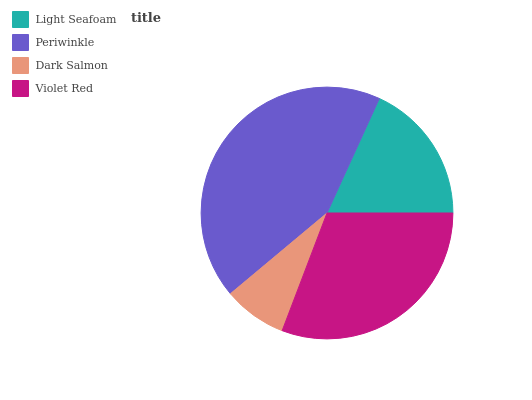Is Dark Salmon the minimum?
Answer yes or no. Yes. Is Periwinkle the maximum?
Answer yes or no. Yes. Is Periwinkle the minimum?
Answer yes or no. No. Is Dark Salmon the maximum?
Answer yes or no. No. Is Periwinkle greater than Dark Salmon?
Answer yes or no. Yes. Is Dark Salmon less than Periwinkle?
Answer yes or no. Yes. Is Dark Salmon greater than Periwinkle?
Answer yes or no. No. Is Periwinkle less than Dark Salmon?
Answer yes or no. No. Is Violet Red the high median?
Answer yes or no. Yes. Is Light Seafoam the low median?
Answer yes or no. Yes. Is Dark Salmon the high median?
Answer yes or no. No. Is Dark Salmon the low median?
Answer yes or no. No. 